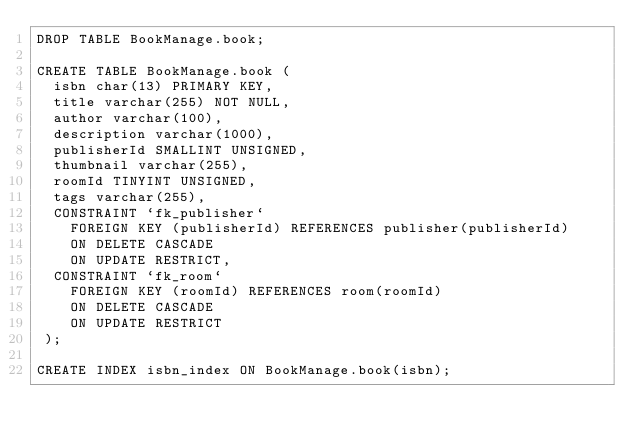Convert code to text. <code><loc_0><loc_0><loc_500><loc_500><_SQL_>DROP TABLE BookManage.book;

CREATE TABLE BookManage.book (
  isbn char(13) PRIMARY KEY,
  title varchar(255) NOT NULL,
  author varchar(100),
  description varchar(1000),
  publisherId SMALLINT UNSIGNED,
  thumbnail varchar(255),
  roomId TINYINT UNSIGNED,
  tags varchar(255),
  CONSTRAINT `fk_publisher`
    FOREIGN KEY (publisherId) REFERENCES publisher(publisherId)
    ON DELETE CASCADE
    ON UPDATE RESTRICT,
  CONSTRAINT `fk_room`
    FOREIGN KEY (roomId) REFERENCES room(roomId)
    ON DELETE CASCADE
    ON UPDATE RESTRICT
 );

CREATE INDEX isbn_index ON BookManage.book(isbn);


</code> 